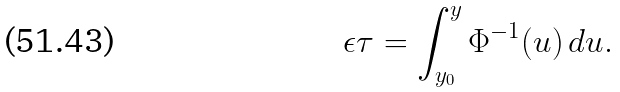Convert formula to latex. <formula><loc_0><loc_0><loc_500><loc_500>\epsilon \tau = \int _ { y _ { 0 } } ^ { y } \Phi ^ { - 1 } ( u ) \, d u .</formula> 